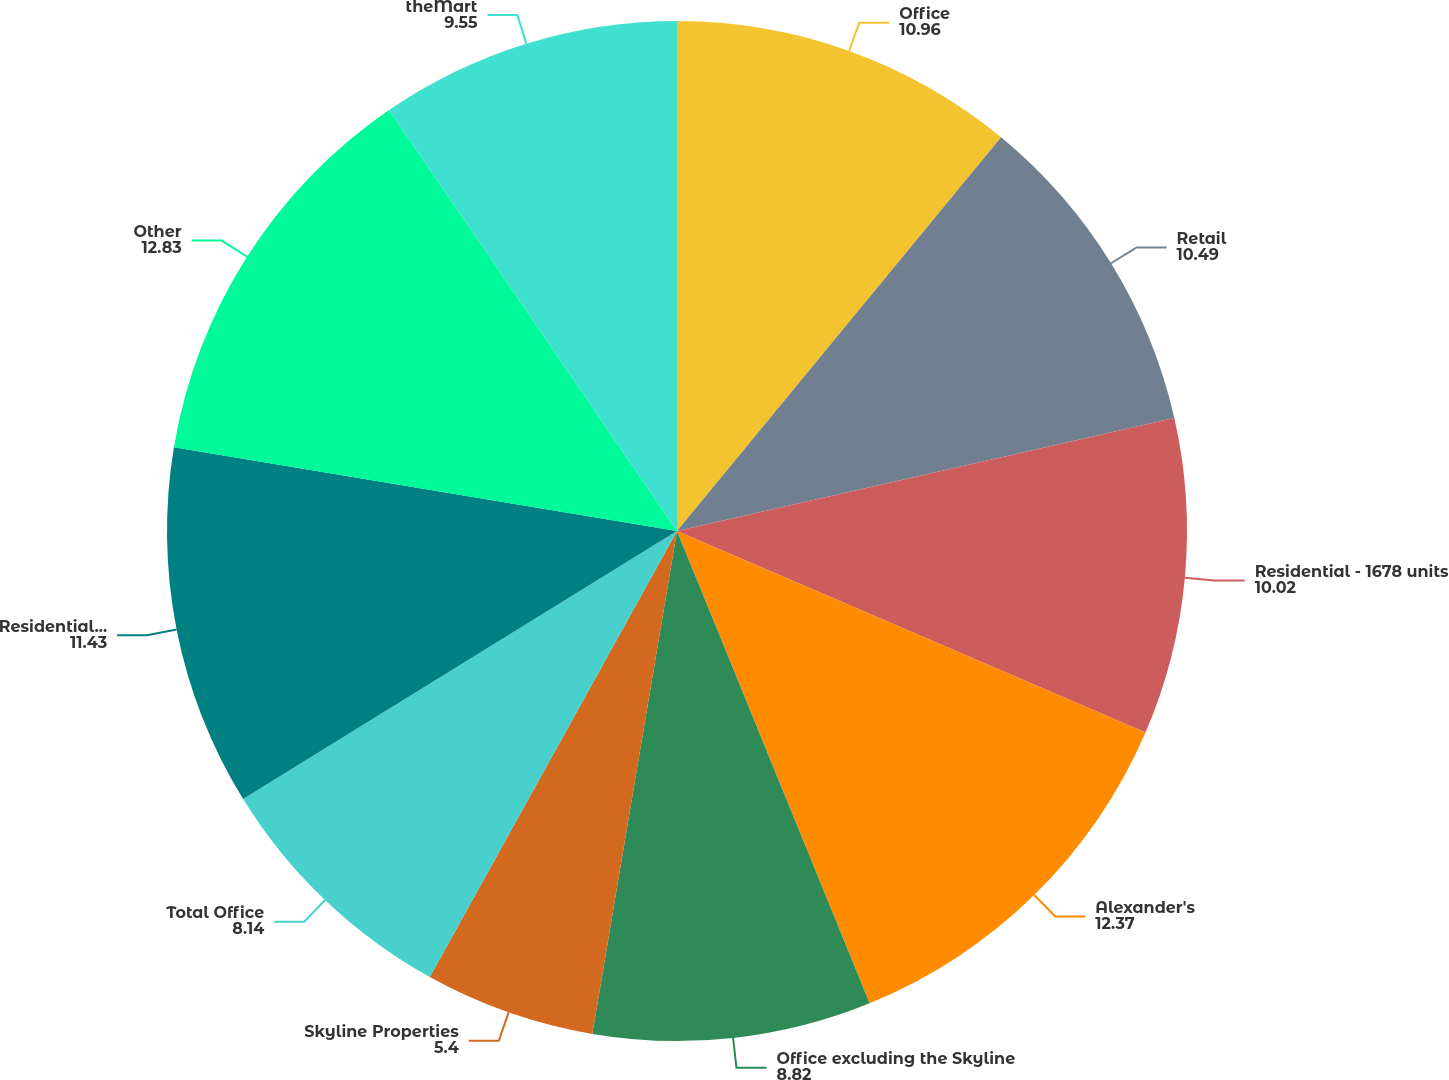Convert chart. <chart><loc_0><loc_0><loc_500><loc_500><pie_chart><fcel>Office<fcel>Retail<fcel>Residential - 1678 units<fcel>Alexander's<fcel>Office excluding the Skyline<fcel>Skyline Properties<fcel>Total Office<fcel>Residential - 2414 units<fcel>Other<fcel>theMart<nl><fcel>10.96%<fcel>10.49%<fcel>10.02%<fcel>12.37%<fcel>8.82%<fcel>5.4%<fcel>8.14%<fcel>11.43%<fcel>12.83%<fcel>9.55%<nl></chart> 